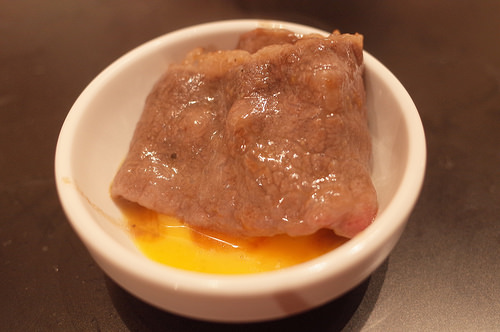<image>
Is there a meat in the bowl? Yes. The meat is contained within or inside the bowl, showing a containment relationship. 